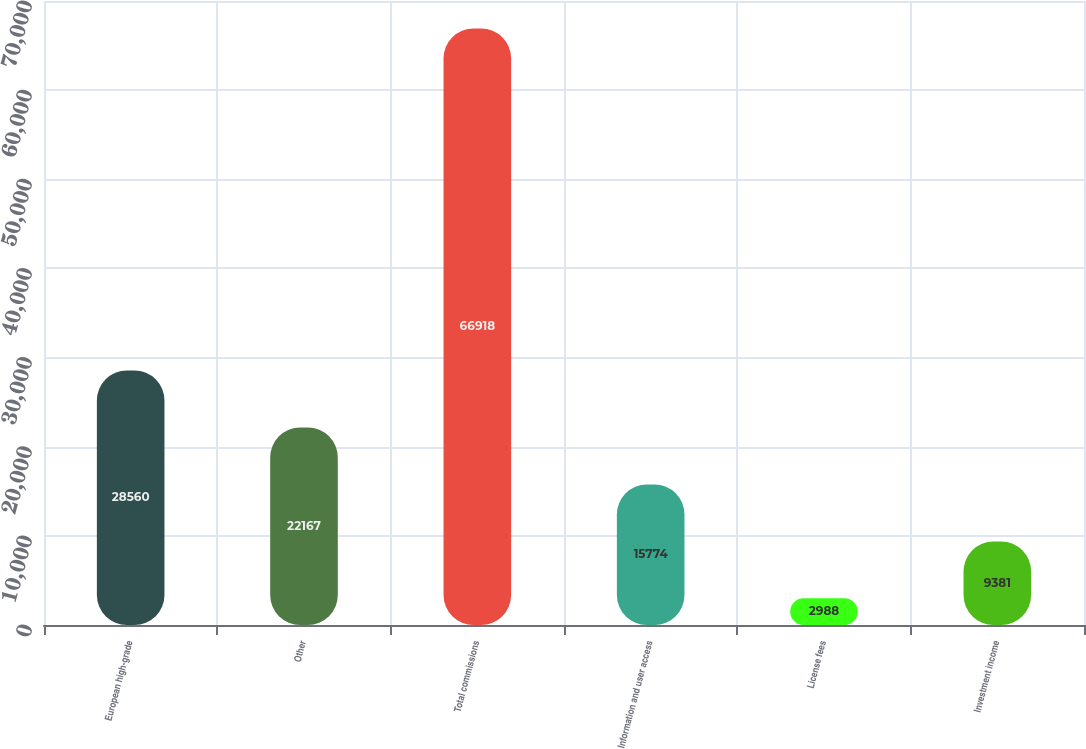Convert chart to OTSL. <chart><loc_0><loc_0><loc_500><loc_500><bar_chart><fcel>European high-grade<fcel>Other<fcel>Total commissions<fcel>Information and user access<fcel>License fees<fcel>Investment income<nl><fcel>28560<fcel>22167<fcel>66918<fcel>15774<fcel>2988<fcel>9381<nl></chart> 